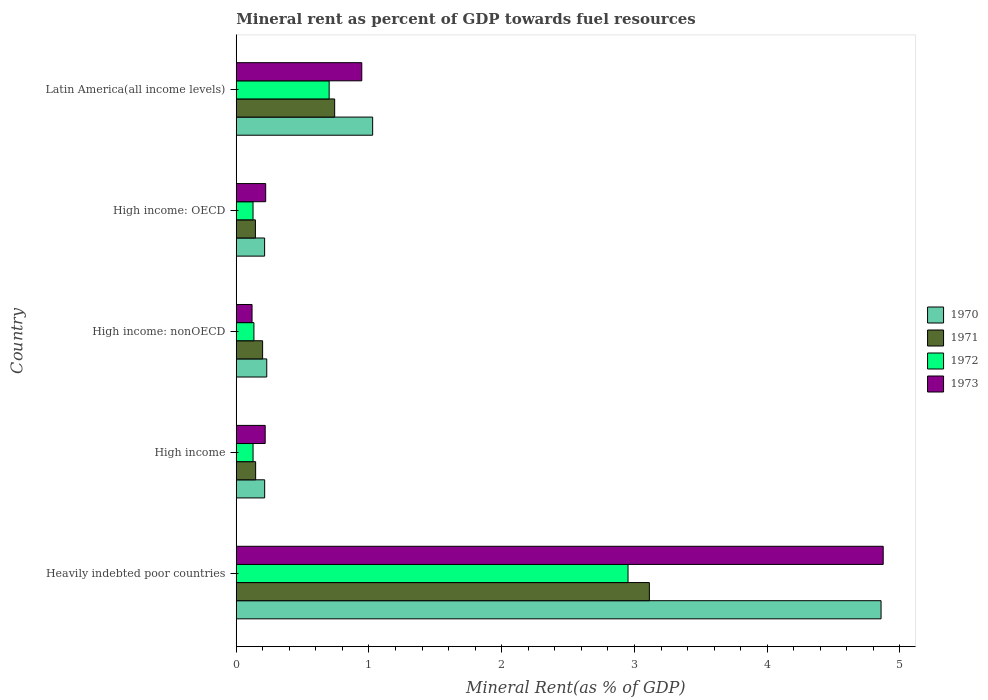How many different coloured bars are there?
Keep it short and to the point. 4. How many groups of bars are there?
Your answer should be very brief. 5. Are the number of bars per tick equal to the number of legend labels?
Keep it short and to the point. Yes. How many bars are there on the 1st tick from the bottom?
Your response must be concise. 4. In how many cases, is the number of bars for a given country not equal to the number of legend labels?
Ensure brevity in your answer.  0. What is the mineral rent in 1973 in Heavily indebted poor countries?
Give a very brief answer. 4.87. Across all countries, what is the maximum mineral rent in 1971?
Offer a terse response. 3.11. Across all countries, what is the minimum mineral rent in 1970?
Provide a succinct answer. 0.21. In which country was the mineral rent in 1973 maximum?
Provide a succinct answer. Heavily indebted poor countries. In which country was the mineral rent in 1973 minimum?
Provide a succinct answer. High income: nonOECD. What is the total mineral rent in 1970 in the graph?
Make the answer very short. 6.54. What is the difference between the mineral rent in 1970 in High income: OECD and that in Latin America(all income levels)?
Your response must be concise. -0.81. What is the difference between the mineral rent in 1973 in Heavily indebted poor countries and the mineral rent in 1971 in High income: OECD?
Keep it short and to the point. 4.73. What is the average mineral rent in 1973 per country?
Ensure brevity in your answer.  1.28. What is the difference between the mineral rent in 1971 and mineral rent in 1972 in High income?
Make the answer very short. 0.02. What is the ratio of the mineral rent in 1972 in High income: OECD to that in Latin America(all income levels)?
Provide a short and direct response. 0.18. Is the mineral rent in 1970 in Heavily indebted poor countries less than that in High income: nonOECD?
Provide a short and direct response. No. What is the difference between the highest and the second highest mineral rent in 1973?
Offer a very short reply. 3.93. What is the difference between the highest and the lowest mineral rent in 1971?
Your answer should be very brief. 2.97. Is it the case that in every country, the sum of the mineral rent in 1972 and mineral rent in 1973 is greater than the sum of mineral rent in 1970 and mineral rent in 1971?
Your answer should be compact. No. What does the 1st bar from the bottom in High income represents?
Give a very brief answer. 1970. Is it the case that in every country, the sum of the mineral rent in 1971 and mineral rent in 1972 is greater than the mineral rent in 1973?
Provide a succinct answer. Yes. Are all the bars in the graph horizontal?
Give a very brief answer. Yes. How many countries are there in the graph?
Offer a terse response. 5. How are the legend labels stacked?
Give a very brief answer. Vertical. What is the title of the graph?
Keep it short and to the point. Mineral rent as percent of GDP towards fuel resources. Does "1999" appear as one of the legend labels in the graph?
Make the answer very short. No. What is the label or title of the X-axis?
Provide a succinct answer. Mineral Rent(as % of GDP). What is the label or title of the Y-axis?
Ensure brevity in your answer.  Country. What is the Mineral Rent(as % of GDP) of 1970 in Heavily indebted poor countries?
Provide a short and direct response. 4.86. What is the Mineral Rent(as % of GDP) of 1971 in Heavily indebted poor countries?
Give a very brief answer. 3.11. What is the Mineral Rent(as % of GDP) of 1972 in Heavily indebted poor countries?
Ensure brevity in your answer.  2.95. What is the Mineral Rent(as % of GDP) in 1973 in Heavily indebted poor countries?
Provide a short and direct response. 4.87. What is the Mineral Rent(as % of GDP) in 1970 in High income?
Keep it short and to the point. 0.21. What is the Mineral Rent(as % of GDP) in 1971 in High income?
Provide a short and direct response. 0.15. What is the Mineral Rent(as % of GDP) of 1972 in High income?
Your answer should be compact. 0.13. What is the Mineral Rent(as % of GDP) in 1973 in High income?
Provide a short and direct response. 0.22. What is the Mineral Rent(as % of GDP) in 1970 in High income: nonOECD?
Ensure brevity in your answer.  0.23. What is the Mineral Rent(as % of GDP) in 1971 in High income: nonOECD?
Make the answer very short. 0.2. What is the Mineral Rent(as % of GDP) of 1972 in High income: nonOECD?
Keep it short and to the point. 0.13. What is the Mineral Rent(as % of GDP) of 1973 in High income: nonOECD?
Your answer should be very brief. 0.12. What is the Mineral Rent(as % of GDP) of 1970 in High income: OECD?
Your answer should be compact. 0.21. What is the Mineral Rent(as % of GDP) of 1971 in High income: OECD?
Your answer should be very brief. 0.14. What is the Mineral Rent(as % of GDP) of 1972 in High income: OECD?
Provide a short and direct response. 0.13. What is the Mineral Rent(as % of GDP) of 1973 in High income: OECD?
Your response must be concise. 0.22. What is the Mineral Rent(as % of GDP) in 1970 in Latin America(all income levels)?
Keep it short and to the point. 1.03. What is the Mineral Rent(as % of GDP) of 1971 in Latin America(all income levels)?
Ensure brevity in your answer.  0.74. What is the Mineral Rent(as % of GDP) in 1972 in Latin America(all income levels)?
Ensure brevity in your answer.  0.7. What is the Mineral Rent(as % of GDP) in 1973 in Latin America(all income levels)?
Your response must be concise. 0.95. Across all countries, what is the maximum Mineral Rent(as % of GDP) of 1970?
Keep it short and to the point. 4.86. Across all countries, what is the maximum Mineral Rent(as % of GDP) in 1971?
Provide a succinct answer. 3.11. Across all countries, what is the maximum Mineral Rent(as % of GDP) in 1972?
Give a very brief answer. 2.95. Across all countries, what is the maximum Mineral Rent(as % of GDP) in 1973?
Provide a short and direct response. 4.87. Across all countries, what is the minimum Mineral Rent(as % of GDP) in 1970?
Your answer should be very brief. 0.21. Across all countries, what is the minimum Mineral Rent(as % of GDP) in 1971?
Offer a very short reply. 0.14. Across all countries, what is the minimum Mineral Rent(as % of GDP) in 1972?
Offer a very short reply. 0.13. Across all countries, what is the minimum Mineral Rent(as % of GDP) in 1973?
Offer a very short reply. 0.12. What is the total Mineral Rent(as % of GDP) of 1970 in the graph?
Ensure brevity in your answer.  6.54. What is the total Mineral Rent(as % of GDP) in 1971 in the graph?
Ensure brevity in your answer.  4.34. What is the total Mineral Rent(as % of GDP) in 1972 in the graph?
Your answer should be very brief. 4.04. What is the total Mineral Rent(as % of GDP) in 1973 in the graph?
Provide a succinct answer. 6.38. What is the difference between the Mineral Rent(as % of GDP) of 1970 in Heavily indebted poor countries and that in High income?
Your response must be concise. 4.64. What is the difference between the Mineral Rent(as % of GDP) of 1971 in Heavily indebted poor countries and that in High income?
Provide a succinct answer. 2.97. What is the difference between the Mineral Rent(as % of GDP) of 1972 in Heavily indebted poor countries and that in High income?
Your answer should be very brief. 2.82. What is the difference between the Mineral Rent(as % of GDP) in 1973 in Heavily indebted poor countries and that in High income?
Provide a succinct answer. 4.66. What is the difference between the Mineral Rent(as % of GDP) in 1970 in Heavily indebted poor countries and that in High income: nonOECD?
Provide a succinct answer. 4.63. What is the difference between the Mineral Rent(as % of GDP) in 1971 in Heavily indebted poor countries and that in High income: nonOECD?
Provide a short and direct response. 2.91. What is the difference between the Mineral Rent(as % of GDP) of 1972 in Heavily indebted poor countries and that in High income: nonOECD?
Your answer should be compact. 2.82. What is the difference between the Mineral Rent(as % of GDP) of 1973 in Heavily indebted poor countries and that in High income: nonOECD?
Your answer should be compact. 4.75. What is the difference between the Mineral Rent(as % of GDP) in 1970 in Heavily indebted poor countries and that in High income: OECD?
Your response must be concise. 4.64. What is the difference between the Mineral Rent(as % of GDP) of 1971 in Heavily indebted poor countries and that in High income: OECD?
Your response must be concise. 2.97. What is the difference between the Mineral Rent(as % of GDP) in 1972 in Heavily indebted poor countries and that in High income: OECD?
Give a very brief answer. 2.83. What is the difference between the Mineral Rent(as % of GDP) of 1973 in Heavily indebted poor countries and that in High income: OECD?
Offer a terse response. 4.65. What is the difference between the Mineral Rent(as % of GDP) of 1970 in Heavily indebted poor countries and that in Latin America(all income levels)?
Give a very brief answer. 3.83. What is the difference between the Mineral Rent(as % of GDP) in 1971 in Heavily indebted poor countries and that in Latin America(all income levels)?
Your answer should be very brief. 2.37. What is the difference between the Mineral Rent(as % of GDP) in 1972 in Heavily indebted poor countries and that in Latin America(all income levels)?
Your response must be concise. 2.25. What is the difference between the Mineral Rent(as % of GDP) of 1973 in Heavily indebted poor countries and that in Latin America(all income levels)?
Your response must be concise. 3.93. What is the difference between the Mineral Rent(as % of GDP) in 1970 in High income and that in High income: nonOECD?
Give a very brief answer. -0.02. What is the difference between the Mineral Rent(as % of GDP) in 1971 in High income and that in High income: nonOECD?
Ensure brevity in your answer.  -0.05. What is the difference between the Mineral Rent(as % of GDP) in 1972 in High income and that in High income: nonOECD?
Ensure brevity in your answer.  -0.01. What is the difference between the Mineral Rent(as % of GDP) in 1973 in High income and that in High income: nonOECD?
Your answer should be very brief. 0.1. What is the difference between the Mineral Rent(as % of GDP) in 1971 in High income and that in High income: OECD?
Your answer should be compact. 0. What is the difference between the Mineral Rent(as % of GDP) of 1972 in High income and that in High income: OECD?
Your answer should be very brief. 0. What is the difference between the Mineral Rent(as % of GDP) in 1973 in High income and that in High income: OECD?
Provide a short and direct response. -0. What is the difference between the Mineral Rent(as % of GDP) of 1970 in High income and that in Latin America(all income levels)?
Ensure brevity in your answer.  -0.81. What is the difference between the Mineral Rent(as % of GDP) of 1971 in High income and that in Latin America(all income levels)?
Provide a succinct answer. -0.6. What is the difference between the Mineral Rent(as % of GDP) in 1972 in High income and that in Latin America(all income levels)?
Ensure brevity in your answer.  -0.57. What is the difference between the Mineral Rent(as % of GDP) of 1973 in High income and that in Latin America(all income levels)?
Your answer should be very brief. -0.73. What is the difference between the Mineral Rent(as % of GDP) of 1970 in High income: nonOECD and that in High income: OECD?
Offer a very short reply. 0.02. What is the difference between the Mineral Rent(as % of GDP) in 1971 in High income: nonOECD and that in High income: OECD?
Keep it short and to the point. 0.05. What is the difference between the Mineral Rent(as % of GDP) in 1972 in High income: nonOECD and that in High income: OECD?
Offer a very short reply. 0.01. What is the difference between the Mineral Rent(as % of GDP) in 1973 in High income: nonOECD and that in High income: OECD?
Keep it short and to the point. -0.1. What is the difference between the Mineral Rent(as % of GDP) in 1970 in High income: nonOECD and that in Latin America(all income levels)?
Your response must be concise. -0.8. What is the difference between the Mineral Rent(as % of GDP) of 1971 in High income: nonOECD and that in Latin America(all income levels)?
Give a very brief answer. -0.54. What is the difference between the Mineral Rent(as % of GDP) of 1972 in High income: nonOECD and that in Latin America(all income levels)?
Offer a very short reply. -0.57. What is the difference between the Mineral Rent(as % of GDP) in 1973 in High income: nonOECD and that in Latin America(all income levels)?
Offer a very short reply. -0.83. What is the difference between the Mineral Rent(as % of GDP) in 1970 in High income: OECD and that in Latin America(all income levels)?
Your answer should be compact. -0.81. What is the difference between the Mineral Rent(as % of GDP) of 1971 in High income: OECD and that in Latin America(all income levels)?
Keep it short and to the point. -0.6. What is the difference between the Mineral Rent(as % of GDP) in 1972 in High income: OECD and that in Latin America(all income levels)?
Your answer should be very brief. -0.57. What is the difference between the Mineral Rent(as % of GDP) in 1973 in High income: OECD and that in Latin America(all income levels)?
Your answer should be compact. -0.72. What is the difference between the Mineral Rent(as % of GDP) in 1970 in Heavily indebted poor countries and the Mineral Rent(as % of GDP) in 1971 in High income?
Your response must be concise. 4.71. What is the difference between the Mineral Rent(as % of GDP) of 1970 in Heavily indebted poor countries and the Mineral Rent(as % of GDP) of 1972 in High income?
Provide a succinct answer. 4.73. What is the difference between the Mineral Rent(as % of GDP) in 1970 in Heavily indebted poor countries and the Mineral Rent(as % of GDP) in 1973 in High income?
Your response must be concise. 4.64. What is the difference between the Mineral Rent(as % of GDP) of 1971 in Heavily indebted poor countries and the Mineral Rent(as % of GDP) of 1972 in High income?
Give a very brief answer. 2.99. What is the difference between the Mineral Rent(as % of GDP) in 1971 in Heavily indebted poor countries and the Mineral Rent(as % of GDP) in 1973 in High income?
Offer a terse response. 2.89. What is the difference between the Mineral Rent(as % of GDP) in 1972 in Heavily indebted poor countries and the Mineral Rent(as % of GDP) in 1973 in High income?
Offer a very short reply. 2.73. What is the difference between the Mineral Rent(as % of GDP) in 1970 in Heavily indebted poor countries and the Mineral Rent(as % of GDP) in 1971 in High income: nonOECD?
Your answer should be very brief. 4.66. What is the difference between the Mineral Rent(as % of GDP) in 1970 in Heavily indebted poor countries and the Mineral Rent(as % of GDP) in 1972 in High income: nonOECD?
Make the answer very short. 4.72. What is the difference between the Mineral Rent(as % of GDP) in 1970 in Heavily indebted poor countries and the Mineral Rent(as % of GDP) in 1973 in High income: nonOECD?
Provide a succinct answer. 4.74. What is the difference between the Mineral Rent(as % of GDP) in 1971 in Heavily indebted poor countries and the Mineral Rent(as % of GDP) in 1972 in High income: nonOECD?
Ensure brevity in your answer.  2.98. What is the difference between the Mineral Rent(as % of GDP) in 1971 in Heavily indebted poor countries and the Mineral Rent(as % of GDP) in 1973 in High income: nonOECD?
Give a very brief answer. 2.99. What is the difference between the Mineral Rent(as % of GDP) of 1972 in Heavily indebted poor countries and the Mineral Rent(as % of GDP) of 1973 in High income: nonOECD?
Give a very brief answer. 2.83. What is the difference between the Mineral Rent(as % of GDP) of 1970 in Heavily indebted poor countries and the Mineral Rent(as % of GDP) of 1971 in High income: OECD?
Ensure brevity in your answer.  4.71. What is the difference between the Mineral Rent(as % of GDP) of 1970 in Heavily indebted poor countries and the Mineral Rent(as % of GDP) of 1972 in High income: OECD?
Keep it short and to the point. 4.73. What is the difference between the Mineral Rent(as % of GDP) in 1970 in Heavily indebted poor countries and the Mineral Rent(as % of GDP) in 1973 in High income: OECD?
Give a very brief answer. 4.64. What is the difference between the Mineral Rent(as % of GDP) in 1971 in Heavily indebted poor countries and the Mineral Rent(as % of GDP) in 1972 in High income: OECD?
Give a very brief answer. 2.99. What is the difference between the Mineral Rent(as % of GDP) in 1971 in Heavily indebted poor countries and the Mineral Rent(as % of GDP) in 1973 in High income: OECD?
Your response must be concise. 2.89. What is the difference between the Mineral Rent(as % of GDP) of 1972 in Heavily indebted poor countries and the Mineral Rent(as % of GDP) of 1973 in High income: OECD?
Your response must be concise. 2.73. What is the difference between the Mineral Rent(as % of GDP) in 1970 in Heavily indebted poor countries and the Mineral Rent(as % of GDP) in 1971 in Latin America(all income levels)?
Give a very brief answer. 4.12. What is the difference between the Mineral Rent(as % of GDP) in 1970 in Heavily indebted poor countries and the Mineral Rent(as % of GDP) in 1972 in Latin America(all income levels)?
Your answer should be compact. 4.16. What is the difference between the Mineral Rent(as % of GDP) of 1970 in Heavily indebted poor countries and the Mineral Rent(as % of GDP) of 1973 in Latin America(all income levels)?
Keep it short and to the point. 3.91. What is the difference between the Mineral Rent(as % of GDP) of 1971 in Heavily indebted poor countries and the Mineral Rent(as % of GDP) of 1972 in Latin America(all income levels)?
Your answer should be very brief. 2.41. What is the difference between the Mineral Rent(as % of GDP) of 1971 in Heavily indebted poor countries and the Mineral Rent(as % of GDP) of 1973 in Latin America(all income levels)?
Provide a succinct answer. 2.17. What is the difference between the Mineral Rent(as % of GDP) in 1972 in Heavily indebted poor countries and the Mineral Rent(as % of GDP) in 1973 in Latin America(all income levels)?
Your answer should be very brief. 2.01. What is the difference between the Mineral Rent(as % of GDP) in 1970 in High income and the Mineral Rent(as % of GDP) in 1971 in High income: nonOECD?
Provide a short and direct response. 0.02. What is the difference between the Mineral Rent(as % of GDP) in 1970 in High income and the Mineral Rent(as % of GDP) in 1972 in High income: nonOECD?
Provide a short and direct response. 0.08. What is the difference between the Mineral Rent(as % of GDP) in 1970 in High income and the Mineral Rent(as % of GDP) in 1973 in High income: nonOECD?
Ensure brevity in your answer.  0.1. What is the difference between the Mineral Rent(as % of GDP) in 1971 in High income and the Mineral Rent(as % of GDP) in 1972 in High income: nonOECD?
Provide a succinct answer. 0.01. What is the difference between the Mineral Rent(as % of GDP) of 1971 in High income and the Mineral Rent(as % of GDP) of 1973 in High income: nonOECD?
Give a very brief answer. 0.03. What is the difference between the Mineral Rent(as % of GDP) in 1972 in High income and the Mineral Rent(as % of GDP) in 1973 in High income: nonOECD?
Your response must be concise. 0.01. What is the difference between the Mineral Rent(as % of GDP) in 1970 in High income and the Mineral Rent(as % of GDP) in 1971 in High income: OECD?
Offer a very short reply. 0.07. What is the difference between the Mineral Rent(as % of GDP) of 1970 in High income and the Mineral Rent(as % of GDP) of 1972 in High income: OECD?
Provide a short and direct response. 0.09. What is the difference between the Mineral Rent(as % of GDP) of 1970 in High income and the Mineral Rent(as % of GDP) of 1973 in High income: OECD?
Give a very brief answer. -0.01. What is the difference between the Mineral Rent(as % of GDP) in 1971 in High income and the Mineral Rent(as % of GDP) in 1972 in High income: OECD?
Your answer should be very brief. 0.02. What is the difference between the Mineral Rent(as % of GDP) in 1971 in High income and the Mineral Rent(as % of GDP) in 1973 in High income: OECD?
Your response must be concise. -0.08. What is the difference between the Mineral Rent(as % of GDP) of 1972 in High income and the Mineral Rent(as % of GDP) of 1973 in High income: OECD?
Your answer should be very brief. -0.1. What is the difference between the Mineral Rent(as % of GDP) in 1970 in High income and the Mineral Rent(as % of GDP) in 1971 in Latin America(all income levels)?
Offer a very short reply. -0.53. What is the difference between the Mineral Rent(as % of GDP) of 1970 in High income and the Mineral Rent(as % of GDP) of 1972 in Latin America(all income levels)?
Provide a short and direct response. -0.49. What is the difference between the Mineral Rent(as % of GDP) of 1970 in High income and the Mineral Rent(as % of GDP) of 1973 in Latin America(all income levels)?
Your answer should be compact. -0.73. What is the difference between the Mineral Rent(as % of GDP) of 1971 in High income and the Mineral Rent(as % of GDP) of 1972 in Latin America(all income levels)?
Offer a terse response. -0.55. What is the difference between the Mineral Rent(as % of GDP) in 1971 in High income and the Mineral Rent(as % of GDP) in 1973 in Latin America(all income levels)?
Your response must be concise. -0.8. What is the difference between the Mineral Rent(as % of GDP) of 1972 in High income and the Mineral Rent(as % of GDP) of 1973 in Latin America(all income levels)?
Your answer should be very brief. -0.82. What is the difference between the Mineral Rent(as % of GDP) of 1970 in High income: nonOECD and the Mineral Rent(as % of GDP) of 1971 in High income: OECD?
Your answer should be compact. 0.09. What is the difference between the Mineral Rent(as % of GDP) of 1970 in High income: nonOECD and the Mineral Rent(as % of GDP) of 1972 in High income: OECD?
Your answer should be compact. 0.1. What is the difference between the Mineral Rent(as % of GDP) in 1970 in High income: nonOECD and the Mineral Rent(as % of GDP) in 1973 in High income: OECD?
Provide a short and direct response. 0.01. What is the difference between the Mineral Rent(as % of GDP) of 1971 in High income: nonOECD and the Mineral Rent(as % of GDP) of 1972 in High income: OECD?
Your answer should be very brief. 0.07. What is the difference between the Mineral Rent(as % of GDP) in 1971 in High income: nonOECD and the Mineral Rent(as % of GDP) in 1973 in High income: OECD?
Offer a terse response. -0.02. What is the difference between the Mineral Rent(as % of GDP) in 1972 in High income: nonOECD and the Mineral Rent(as % of GDP) in 1973 in High income: OECD?
Provide a short and direct response. -0.09. What is the difference between the Mineral Rent(as % of GDP) in 1970 in High income: nonOECD and the Mineral Rent(as % of GDP) in 1971 in Latin America(all income levels)?
Your response must be concise. -0.51. What is the difference between the Mineral Rent(as % of GDP) of 1970 in High income: nonOECD and the Mineral Rent(as % of GDP) of 1972 in Latin America(all income levels)?
Make the answer very short. -0.47. What is the difference between the Mineral Rent(as % of GDP) of 1970 in High income: nonOECD and the Mineral Rent(as % of GDP) of 1973 in Latin America(all income levels)?
Offer a terse response. -0.72. What is the difference between the Mineral Rent(as % of GDP) of 1971 in High income: nonOECD and the Mineral Rent(as % of GDP) of 1972 in Latin America(all income levels)?
Give a very brief answer. -0.5. What is the difference between the Mineral Rent(as % of GDP) in 1971 in High income: nonOECD and the Mineral Rent(as % of GDP) in 1973 in Latin America(all income levels)?
Provide a short and direct response. -0.75. What is the difference between the Mineral Rent(as % of GDP) in 1972 in High income: nonOECD and the Mineral Rent(as % of GDP) in 1973 in Latin America(all income levels)?
Ensure brevity in your answer.  -0.81. What is the difference between the Mineral Rent(as % of GDP) in 1970 in High income: OECD and the Mineral Rent(as % of GDP) in 1971 in Latin America(all income levels)?
Your response must be concise. -0.53. What is the difference between the Mineral Rent(as % of GDP) of 1970 in High income: OECD and the Mineral Rent(as % of GDP) of 1972 in Latin America(all income levels)?
Your answer should be compact. -0.49. What is the difference between the Mineral Rent(as % of GDP) of 1970 in High income: OECD and the Mineral Rent(as % of GDP) of 1973 in Latin America(all income levels)?
Offer a terse response. -0.73. What is the difference between the Mineral Rent(as % of GDP) of 1971 in High income: OECD and the Mineral Rent(as % of GDP) of 1972 in Latin America(all income levels)?
Your response must be concise. -0.56. What is the difference between the Mineral Rent(as % of GDP) of 1971 in High income: OECD and the Mineral Rent(as % of GDP) of 1973 in Latin America(all income levels)?
Make the answer very short. -0.8. What is the difference between the Mineral Rent(as % of GDP) of 1972 in High income: OECD and the Mineral Rent(as % of GDP) of 1973 in Latin America(all income levels)?
Ensure brevity in your answer.  -0.82. What is the average Mineral Rent(as % of GDP) in 1970 per country?
Ensure brevity in your answer.  1.31. What is the average Mineral Rent(as % of GDP) of 1971 per country?
Provide a succinct answer. 0.87. What is the average Mineral Rent(as % of GDP) in 1972 per country?
Your answer should be compact. 0.81. What is the average Mineral Rent(as % of GDP) of 1973 per country?
Provide a short and direct response. 1.28. What is the difference between the Mineral Rent(as % of GDP) in 1970 and Mineral Rent(as % of GDP) in 1971 in Heavily indebted poor countries?
Make the answer very short. 1.75. What is the difference between the Mineral Rent(as % of GDP) in 1970 and Mineral Rent(as % of GDP) in 1972 in Heavily indebted poor countries?
Your response must be concise. 1.91. What is the difference between the Mineral Rent(as % of GDP) of 1970 and Mineral Rent(as % of GDP) of 1973 in Heavily indebted poor countries?
Offer a very short reply. -0.02. What is the difference between the Mineral Rent(as % of GDP) in 1971 and Mineral Rent(as % of GDP) in 1972 in Heavily indebted poor countries?
Your answer should be very brief. 0.16. What is the difference between the Mineral Rent(as % of GDP) of 1971 and Mineral Rent(as % of GDP) of 1973 in Heavily indebted poor countries?
Offer a terse response. -1.76. What is the difference between the Mineral Rent(as % of GDP) in 1972 and Mineral Rent(as % of GDP) in 1973 in Heavily indebted poor countries?
Give a very brief answer. -1.92. What is the difference between the Mineral Rent(as % of GDP) of 1970 and Mineral Rent(as % of GDP) of 1971 in High income?
Keep it short and to the point. 0.07. What is the difference between the Mineral Rent(as % of GDP) of 1970 and Mineral Rent(as % of GDP) of 1972 in High income?
Your response must be concise. 0.09. What is the difference between the Mineral Rent(as % of GDP) in 1970 and Mineral Rent(as % of GDP) in 1973 in High income?
Provide a short and direct response. -0. What is the difference between the Mineral Rent(as % of GDP) in 1971 and Mineral Rent(as % of GDP) in 1972 in High income?
Provide a succinct answer. 0.02. What is the difference between the Mineral Rent(as % of GDP) in 1971 and Mineral Rent(as % of GDP) in 1973 in High income?
Ensure brevity in your answer.  -0.07. What is the difference between the Mineral Rent(as % of GDP) of 1972 and Mineral Rent(as % of GDP) of 1973 in High income?
Provide a succinct answer. -0.09. What is the difference between the Mineral Rent(as % of GDP) of 1970 and Mineral Rent(as % of GDP) of 1971 in High income: nonOECD?
Your response must be concise. 0.03. What is the difference between the Mineral Rent(as % of GDP) of 1970 and Mineral Rent(as % of GDP) of 1972 in High income: nonOECD?
Your answer should be compact. 0.1. What is the difference between the Mineral Rent(as % of GDP) of 1970 and Mineral Rent(as % of GDP) of 1973 in High income: nonOECD?
Offer a terse response. 0.11. What is the difference between the Mineral Rent(as % of GDP) in 1971 and Mineral Rent(as % of GDP) in 1972 in High income: nonOECD?
Ensure brevity in your answer.  0.07. What is the difference between the Mineral Rent(as % of GDP) of 1971 and Mineral Rent(as % of GDP) of 1973 in High income: nonOECD?
Your answer should be compact. 0.08. What is the difference between the Mineral Rent(as % of GDP) in 1972 and Mineral Rent(as % of GDP) in 1973 in High income: nonOECD?
Provide a succinct answer. 0.01. What is the difference between the Mineral Rent(as % of GDP) of 1970 and Mineral Rent(as % of GDP) of 1971 in High income: OECD?
Provide a short and direct response. 0.07. What is the difference between the Mineral Rent(as % of GDP) in 1970 and Mineral Rent(as % of GDP) in 1972 in High income: OECD?
Offer a terse response. 0.09. What is the difference between the Mineral Rent(as % of GDP) of 1970 and Mineral Rent(as % of GDP) of 1973 in High income: OECD?
Ensure brevity in your answer.  -0.01. What is the difference between the Mineral Rent(as % of GDP) of 1971 and Mineral Rent(as % of GDP) of 1972 in High income: OECD?
Offer a terse response. 0.02. What is the difference between the Mineral Rent(as % of GDP) in 1971 and Mineral Rent(as % of GDP) in 1973 in High income: OECD?
Your answer should be very brief. -0.08. What is the difference between the Mineral Rent(as % of GDP) of 1972 and Mineral Rent(as % of GDP) of 1973 in High income: OECD?
Your answer should be compact. -0.1. What is the difference between the Mineral Rent(as % of GDP) in 1970 and Mineral Rent(as % of GDP) in 1971 in Latin America(all income levels)?
Ensure brevity in your answer.  0.29. What is the difference between the Mineral Rent(as % of GDP) of 1970 and Mineral Rent(as % of GDP) of 1972 in Latin America(all income levels)?
Give a very brief answer. 0.33. What is the difference between the Mineral Rent(as % of GDP) of 1970 and Mineral Rent(as % of GDP) of 1973 in Latin America(all income levels)?
Provide a succinct answer. 0.08. What is the difference between the Mineral Rent(as % of GDP) in 1971 and Mineral Rent(as % of GDP) in 1972 in Latin America(all income levels)?
Give a very brief answer. 0.04. What is the difference between the Mineral Rent(as % of GDP) in 1971 and Mineral Rent(as % of GDP) in 1973 in Latin America(all income levels)?
Provide a succinct answer. -0.2. What is the difference between the Mineral Rent(as % of GDP) in 1972 and Mineral Rent(as % of GDP) in 1973 in Latin America(all income levels)?
Make the answer very short. -0.25. What is the ratio of the Mineral Rent(as % of GDP) of 1970 in Heavily indebted poor countries to that in High income?
Give a very brief answer. 22.69. What is the ratio of the Mineral Rent(as % of GDP) in 1971 in Heavily indebted poor countries to that in High income?
Make the answer very short. 21.31. What is the ratio of the Mineral Rent(as % of GDP) of 1972 in Heavily indebted poor countries to that in High income?
Offer a very short reply. 23.3. What is the ratio of the Mineral Rent(as % of GDP) of 1973 in Heavily indebted poor countries to that in High income?
Offer a very short reply. 22.35. What is the ratio of the Mineral Rent(as % of GDP) of 1970 in Heavily indebted poor countries to that in High income: nonOECD?
Your answer should be compact. 21.14. What is the ratio of the Mineral Rent(as % of GDP) in 1971 in Heavily indebted poor countries to that in High income: nonOECD?
Make the answer very short. 15.68. What is the ratio of the Mineral Rent(as % of GDP) of 1972 in Heavily indebted poor countries to that in High income: nonOECD?
Make the answer very short. 22.17. What is the ratio of the Mineral Rent(as % of GDP) in 1973 in Heavily indebted poor countries to that in High income: nonOECD?
Provide a short and direct response. 40.95. What is the ratio of the Mineral Rent(as % of GDP) of 1970 in Heavily indebted poor countries to that in High income: OECD?
Provide a succinct answer. 22.74. What is the ratio of the Mineral Rent(as % of GDP) in 1971 in Heavily indebted poor countries to that in High income: OECD?
Offer a very short reply. 21.57. What is the ratio of the Mineral Rent(as % of GDP) of 1972 in Heavily indebted poor countries to that in High income: OECD?
Offer a terse response. 23.34. What is the ratio of the Mineral Rent(as % of GDP) in 1973 in Heavily indebted poor countries to that in High income: OECD?
Your response must be concise. 21.98. What is the ratio of the Mineral Rent(as % of GDP) of 1970 in Heavily indebted poor countries to that in Latin America(all income levels)?
Offer a terse response. 4.73. What is the ratio of the Mineral Rent(as % of GDP) in 1971 in Heavily indebted poor countries to that in Latin America(all income levels)?
Offer a very short reply. 4.2. What is the ratio of the Mineral Rent(as % of GDP) of 1972 in Heavily indebted poor countries to that in Latin America(all income levels)?
Provide a short and direct response. 4.22. What is the ratio of the Mineral Rent(as % of GDP) of 1973 in Heavily indebted poor countries to that in Latin America(all income levels)?
Your response must be concise. 5.15. What is the ratio of the Mineral Rent(as % of GDP) of 1970 in High income to that in High income: nonOECD?
Provide a short and direct response. 0.93. What is the ratio of the Mineral Rent(as % of GDP) in 1971 in High income to that in High income: nonOECD?
Offer a very short reply. 0.74. What is the ratio of the Mineral Rent(as % of GDP) of 1972 in High income to that in High income: nonOECD?
Offer a terse response. 0.95. What is the ratio of the Mineral Rent(as % of GDP) in 1973 in High income to that in High income: nonOECD?
Ensure brevity in your answer.  1.83. What is the ratio of the Mineral Rent(as % of GDP) of 1970 in High income to that in High income: OECD?
Your response must be concise. 1. What is the ratio of the Mineral Rent(as % of GDP) of 1971 in High income to that in High income: OECD?
Provide a short and direct response. 1.01. What is the ratio of the Mineral Rent(as % of GDP) of 1972 in High income to that in High income: OECD?
Your response must be concise. 1. What is the ratio of the Mineral Rent(as % of GDP) in 1973 in High income to that in High income: OECD?
Your response must be concise. 0.98. What is the ratio of the Mineral Rent(as % of GDP) in 1970 in High income to that in Latin America(all income levels)?
Make the answer very short. 0.21. What is the ratio of the Mineral Rent(as % of GDP) in 1971 in High income to that in Latin America(all income levels)?
Give a very brief answer. 0.2. What is the ratio of the Mineral Rent(as % of GDP) of 1972 in High income to that in Latin America(all income levels)?
Make the answer very short. 0.18. What is the ratio of the Mineral Rent(as % of GDP) of 1973 in High income to that in Latin America(all income levels)?
Your answer should be compact. 0.23. What is the ratio of the Mineral Rent(as % of GDP) in 1970 in High income: nonOECD to that in High income: OECD?
Make the answer very short. 1.08. What is the ratio of the Mineral Rent(as % of GDP) in 1971 in High income: nonOECD to that in High income: OECD?
Your answer should be very brief. 1.38. What is the ratio of the Mineral Rent(as % of GDP) in 1972 in High income: nonOECD to that in High income: OECD?
Provide a succinct answer. 1.05. What is the ratio of the Mineral Rent(as % of GDP) in 1973 in High income: nonOECD to that in High income: OECD?
Your answer should be very brief. 0.54. What is the ratio of the Mineral Rent(as % of GDP) of 1970 in High income: nonOECD to that in Latin America(all income levels)?
Offer a terse response. 0.22. What is the ratio of the Mineral Rent(as % of GDP) in 1971 in High income: nonOECD to that in Latin America(all income levels)?
Your answer should be compact. 0.27. What is the ratio of the Mineral Rent(as % of GDP) of 1972 in High income: nonOECD to that in Latin America(all income levels)?
Ensure brevity in your answer.  0.19. What is the ratio of the Mineral Rent(as % of GDP) of 1973 in High income: nonOECD to that in Latin America(all income levels)?
Your answer should be compact. 0.13. What is the ratio of the Mineral Rent(as % of GDP) of 1970 in High income: OECD to that in Latin America(all income levels)?
Give a very brief answer. 0.21. What is the ratio of the Mineral Rent(as % of GDP) in 1971 in High income: OECD to that in Latin America(all income levels)?
Provide a short and direct response. 0.19. What is the ratio of the Mineral Rent(as % of GDP) of 1972 in High income: OECD to that in Latin America(all income levels)?
Give a very brief answer. 0.18. What is the ratio of the Mineral Rent(as % of GDP) in 1973 in High income: OECD to that in Latin America(all income levels)?
Provide a short and direct response. 0.23. What is the difference between the highest and the second highest Mineral Rent(as % of GDP) of 1970?
Give a very brief answer. 3.83. What is the difference between the highest and the second highest Mineral Rent(as % of GDP) of 1971?
Provide a succinct answer. 2.37. What is the difference between the highest and the second highest Mineral Rent(as % of GDP) in 1972?
Provide a succinct answer. 2.25. What is the difference between the highest and the second highest Mineral Rent(as % of GDP) in 1973?
Ensure brevity in your answer.  3.93. What is the difference between the highest and the lowest Mineral Rent(as % of GDP) of 1970?
Ensure brevity in your answer.  4.64. What is the difference between the highest and the lowest Mineral Rent(as % of GDP) in 1971?
Your answer should be very brief. 2.97. What is the difference between the highest and the lowest Mineral Rent(as % of GDP) in 1972?
Offer a terse response. 2.83. What is the difference between the highest and the lowest Mineral Rent(as % of GDP) in 1973?
Make the answer very short. 4.75. 